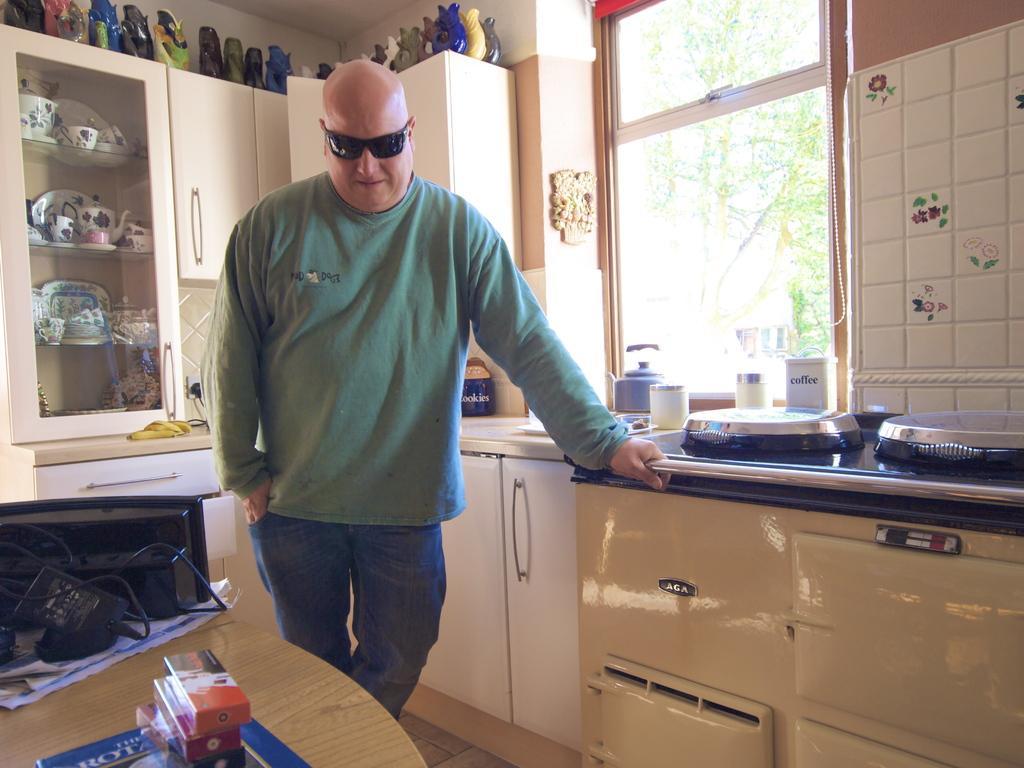In one or two sentences, can you explain what this image depicts? This is an inside view of a room. Here I can see a man standing by holding a metal rod. In the left bottom there is a table on which few cables, foxes, paper and some other objects are placed. On the right side, I can see the table cabinets. On the table bottles, few other objects are placed. At the top there is a window to the wall. In the background there is a cupboard in which few bowls are arranged. At the top of the rock there are few jars. Through the window we can see the outside view. In the outside there is a tree. 